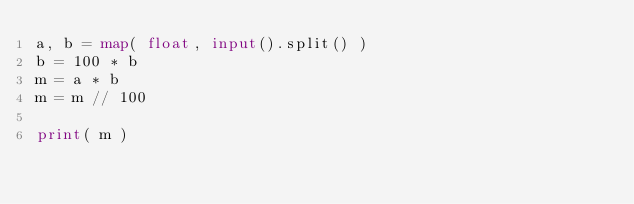<code> <loc_0><loc_0><loc_500><loc_500><_Python_>a, b = map( float, input().split() )
b = 100 * b
m = a * b
m = m // 100

print( m )</code> 